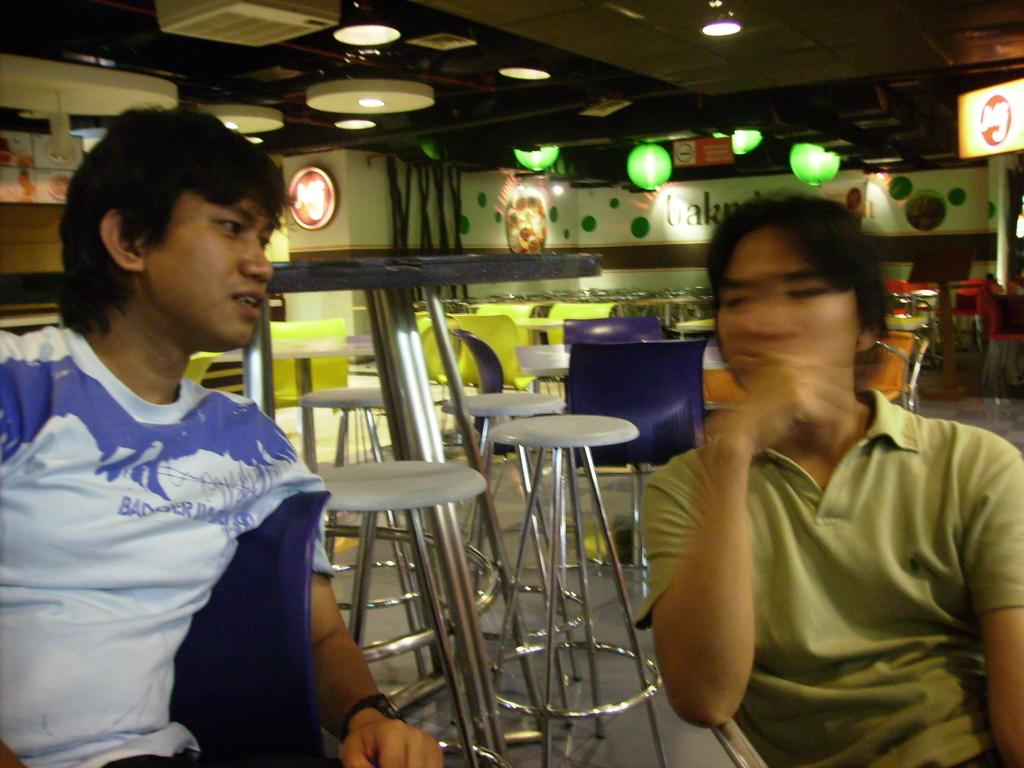How many people are in the image? There are two persons in the image. What are the persons doing in the image? The persons are sitting on chairs. What can be seen in the background of the image? There are tables, chairs, stools, and lights on the ceiling in the background of the image. What type of nail is being hammered into the wall in the image? There is no nail being hammered into the wall in the image. How does the lamp in the image stretch to provide more light? There is no lamp present in the image. 